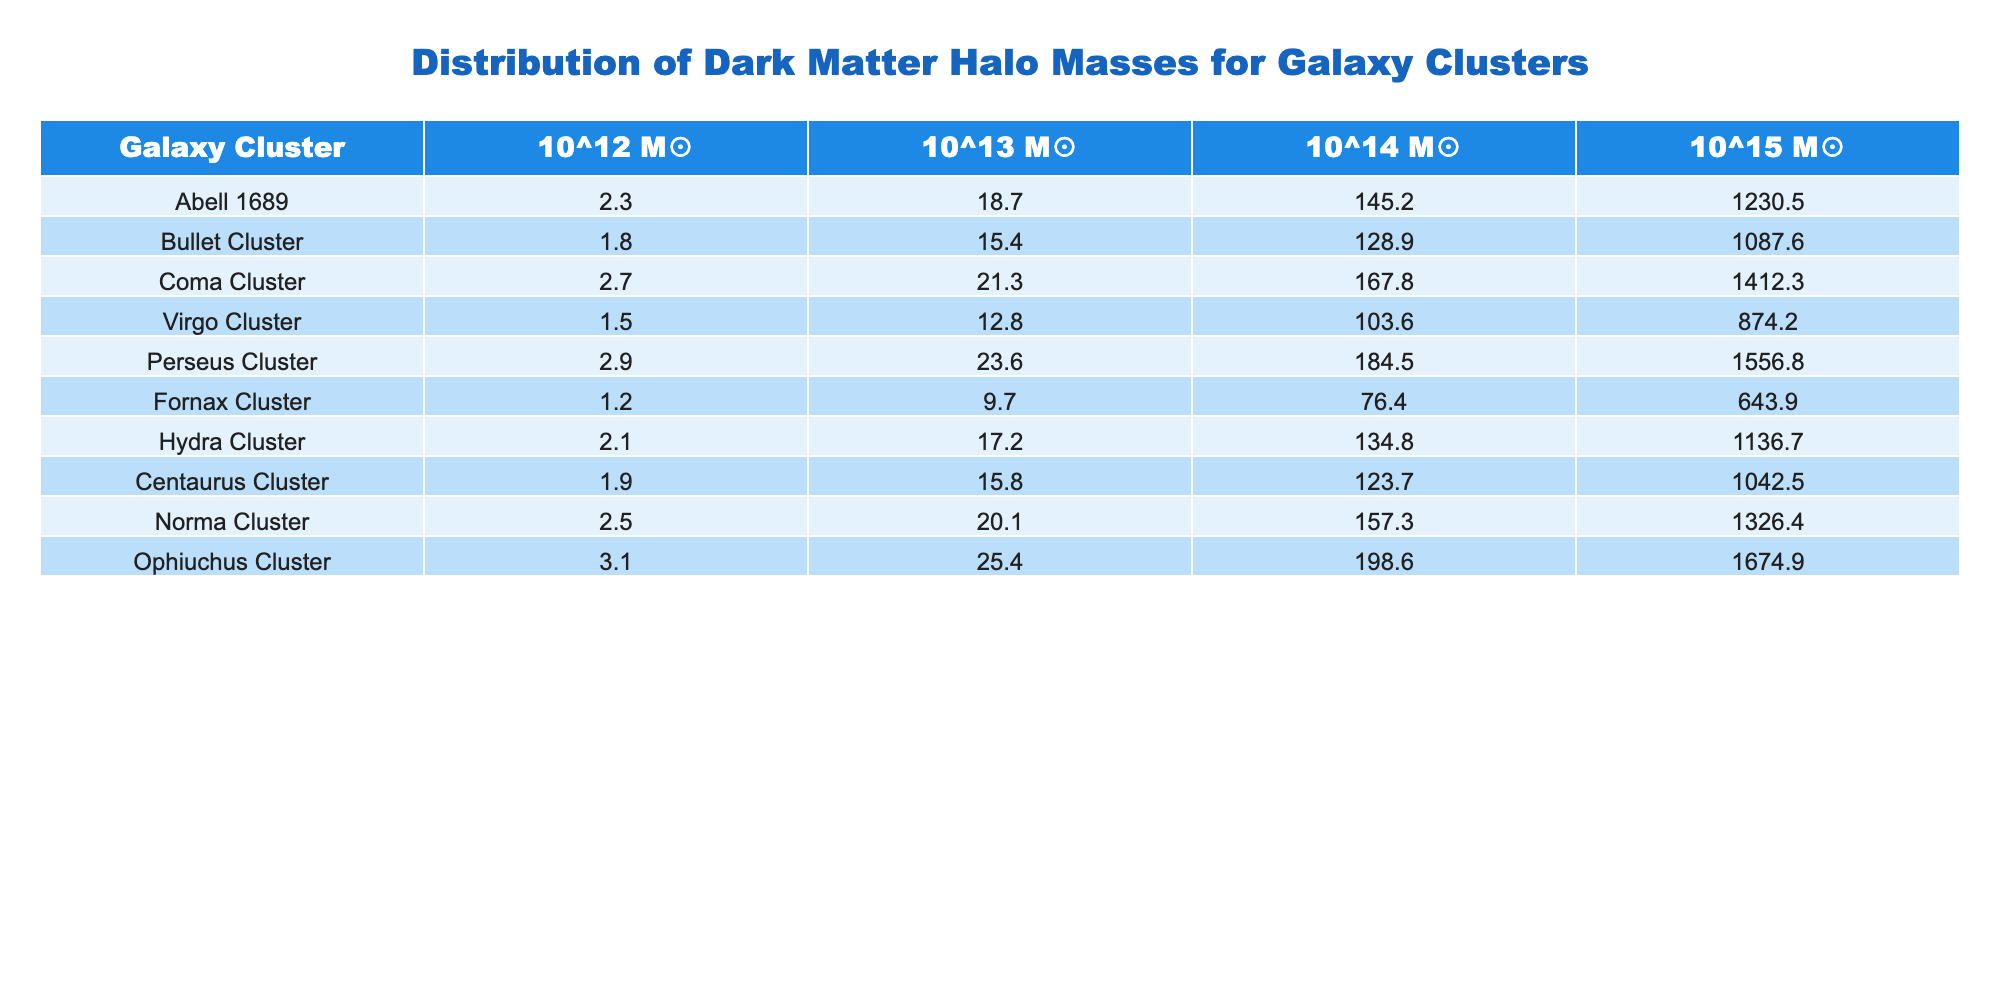What is the mass of the dark matter halo for the Ophiuchus Cluster in 10^14 M☉? The mass for the Ophiuchus Cluster in the 10^14 M☉ column is directly listed in the table as 198.6.
Answer: 198.6 Which cluster has the highest halo mass in the 10^15 M☉ category? By comparing the values in the 10^15 M☉ column, the Ophiuchus Cluster has the highest value of 1674.9, which is greater than all other clusters in this category.
Answer: Ophiuchus Cluster What is the total mass of all clusters combined in the 10^12 M☉ category? To find the total mass in the 10^12 M☉ category, add all values: 2.3 + 1.8 + 2.7 + 1.5 + 2.9 + 1.2 + 2.1 + 1.9 + 2.5 + 3.1 = 21.5.
Answer: 21.5 Which cluster has the lowest dark matter halo mass in the 10^13 M☉ category? Looking at the 10^13 M☉ column, the Fornax Cluster has the lowest mass listed as 9.7.
Answer: Fornax Cluster What is the difference in mass between the highest and lowest values in the 10^14 M☉ column? The highest value in the 10^14 M☉ column is 198.6 (Ophiuchus Cluster) and the lowest is 76.4 (Fornax Cluster). The difference is calculated as 198.6 - 76.4 = 122.2.
Answer: 122.2 Which two clusters have masses closest to each other in the 10^15 M☉ category? A comparison of the values in the 10^15 M☉ column reveals that the masses for the Bullet Cluster (1087.6) and Centaurus Cluster (1042.5) are the closest; the difference is 45.1.
Answer: Bullet and Centaurus Clusters What is the average dark matter halo mass for the Perseus Cluster across all categories? To compute the average for Perseus, sum the values: 2.9 + 23.6 + 184.5 + 1556.8 = 1767.8, then divide by 4 (the number of categories) giving an average of 1767.8 / 4 = 441.95.
Answer: 441.95 Is the dark matter halo mass of the Coma Cluster in the 10^15 M☉ category more than 1500? Checking the Coma Cluster's 10^15 M☉ value of 1412.3 shows it is less than 1500, so the answer is no.
Answer: No Which cluster shows an increasing trend in mass from 10^12 M☉ to 10^15 M☉? By analyzing the rows, the Perseus Cluster shows an increasing trend with values of 2.9, 23.6, 184.5, and 1556.8.
Answer: Perseus Cluster What is the median mass of the Bullet Cluster across all categories? Listing the Bullet Cluster values: 1.8, 15.4, 128.9, 1087.6 and sorting them gives 1.8, 15.4, 128.9, 1087.6. The median (average of two middle numbers) is (15.4 + 128.9) / 2 = 72.15.
Answer: 72.15 